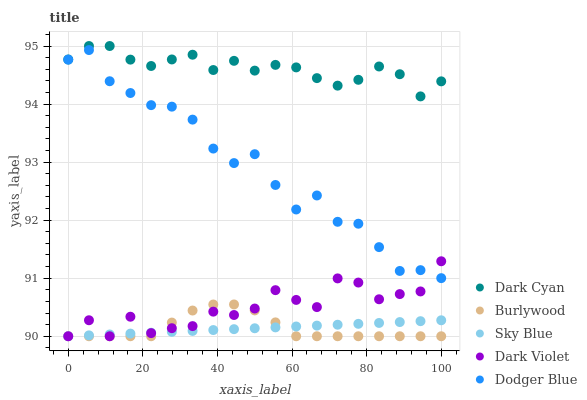Does Burlywood have the minimum area under the curve?
Answer yes or no. Yes. Does Dark Cyan have the maximum area under the curve?
Answer yes or no. Yes. Does Dodger Blue have the minimum area under the curve?
Answer yes or no. No. Does Dodger Blue have the maximum area under the curve?
Answer yes or no. No. Is Sky Blue the smoothest?
Answer yes or no. Yes. Is Dark Violet the roughest?
Answer yes or no. Yes. Is Burlywood the smoothest?
Answer yes or no. No. Is Burlywood the roughest?
Answer yes or no. No. Does Burlywood have the lowest value?
Answer yes or no. Yes. Does Dodger Blue have the lowest value?
Answer yes or no. No. Does Dark Cyan have the highest value?
Answer yes or no. Yes. Does Burlywood have the highest value?
Answer yes or no. No. Is Burlywood less than Dodger Blue?
Answer yes or no. Yes. Is Dark Cyan greater than Burlywood?
Answer yes or no. Yes. Does Dodger Blue intersect Dark Violet?
Answer yes or no. Yes. Is Dodger Blue less than Dark Violet?
Answer yes or no. No. Is Dodger Blue greater than Dark Violet?
Answer yes or no. No. Does Burlywood intersect Dodger Blue?
Answer yes or no. No. 